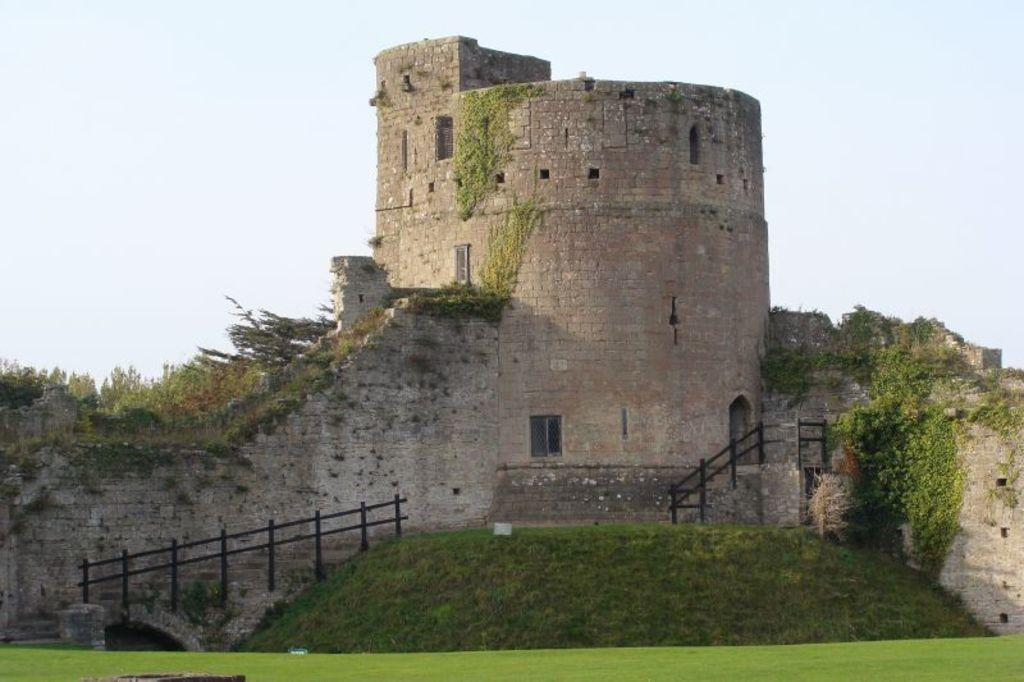What type of surface is visible in the image? There is ground visible in the image. What type of vegetation is present on the ground? There is grass on the ground. What structure is present in the image? There is a fort in the image. What can be seen on the fort? There are plants on the fort. What is visible in the background of the image? The sky is visible in the background of the image. How many cards are being copied by the flock in the image? There are no cards or flocks present in the image. 